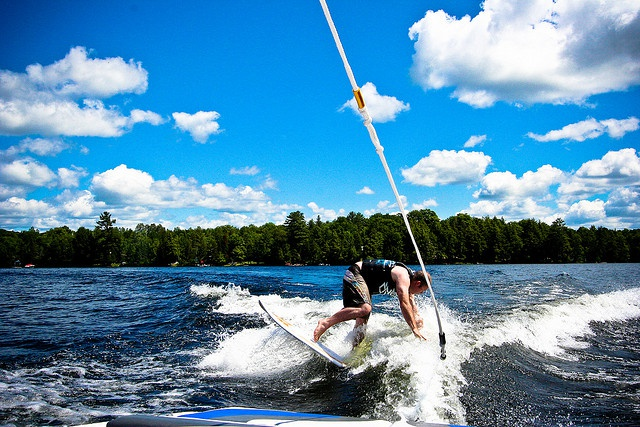Describe the objects in this image and their specific colors. I can see people in navy, black, white, maroon, and darkgray tones and surfboard in navy, white, darkgray, and gray tones in this image. 